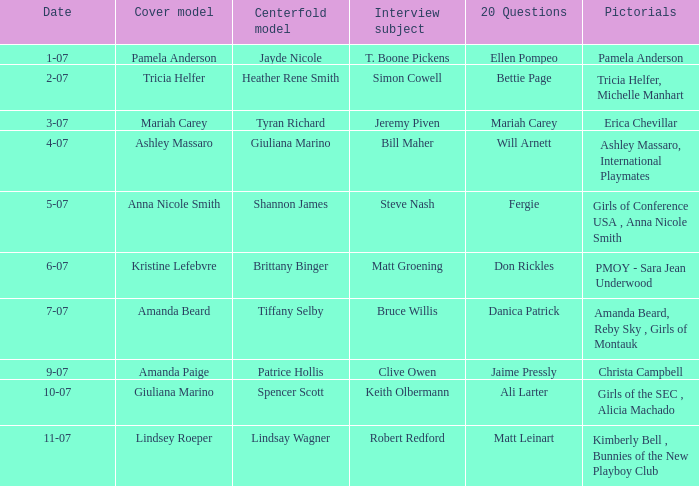Who was the centerfold model when the issue's pictorial was amanda beard, reby sky , girls of montauk ? Tiffany Selby. 